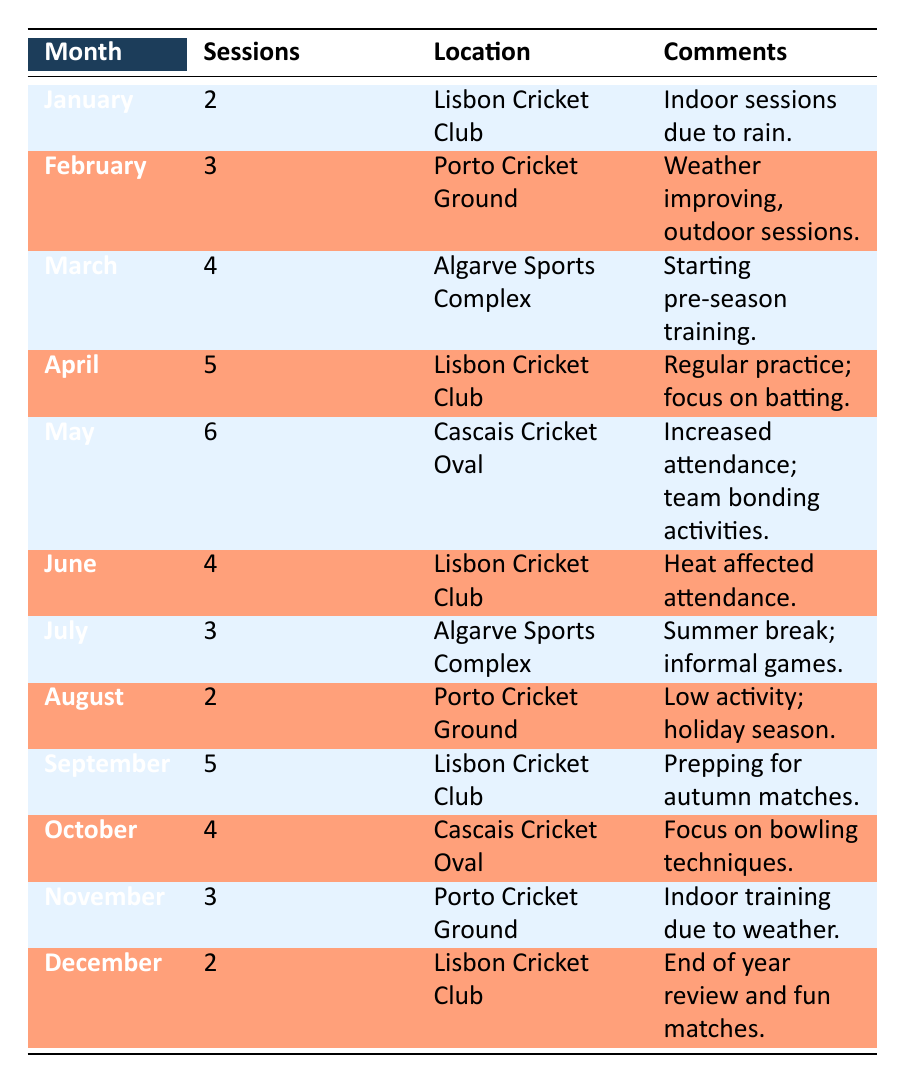What was the highest number of cricket practice sessions in a month? The data shows that the month with the highest number of practice sessions is May, with 6 sessions recorded at the Cascais Cricket Oval.
Answer: 6 In which month did the cricket practice sessions decrease to their lowest point? Looking at the table, both January and August had the lowest number of sessions with 2 each. However, since January was the earlier month, it can be regarded as the first instance of the lowest point.
Answer: January How many sessions were held in total over the year? To find the total, we add the number of sessions from each month: 2 + 3 + 4 + 5 + 6 + 4 + 3 + 2 + 5 + 4 + 3 + 2, which equals 43 sessions in total.
Answer: 43 What is the average number of practice sessions per month across the year? There are 12 months, and the total number of sessions is 43. Calculating the average: 43 divided by 12 is approximately 3.58. Therefore, the average number of sessions per month is rounded to 4.
Answer: 4 Was there a month with more than 5 practice sessions? Yes, the months of May (6 sessions) and April (5 sessions) both had more than 5 practice sessions.
Answer: Yes In which months were practice sessions conducted at the Lisbon Cricket Club? The Lisbon Cricket Club hosted sessions in January, April, June, September, and December, as indicated in the location column for those months.
Answer: January, April, June, September, December Which month experienced a drop in practice sessions after May? After May, which had 6 sessions, June saw a decrease to 4 sessions. Additionally, July saw another drop to 3 sessions. This indicates a trend of falling session numbers.
Answer: June Did sessions increase or decrease from March to April? From March (4 sessions) to April (5 sessions), there was an increase of 1 session.
Answer: Increase What was the most common comment associated with practice sessions? Looking through the comments, there is a consistent theme of discussing weather impacts, such as "Indoor sessions due to rain" in January and "Indoor training due to weather" in November. This illustrates the influence of weather on practice sessions.
Answer: Weather impact 